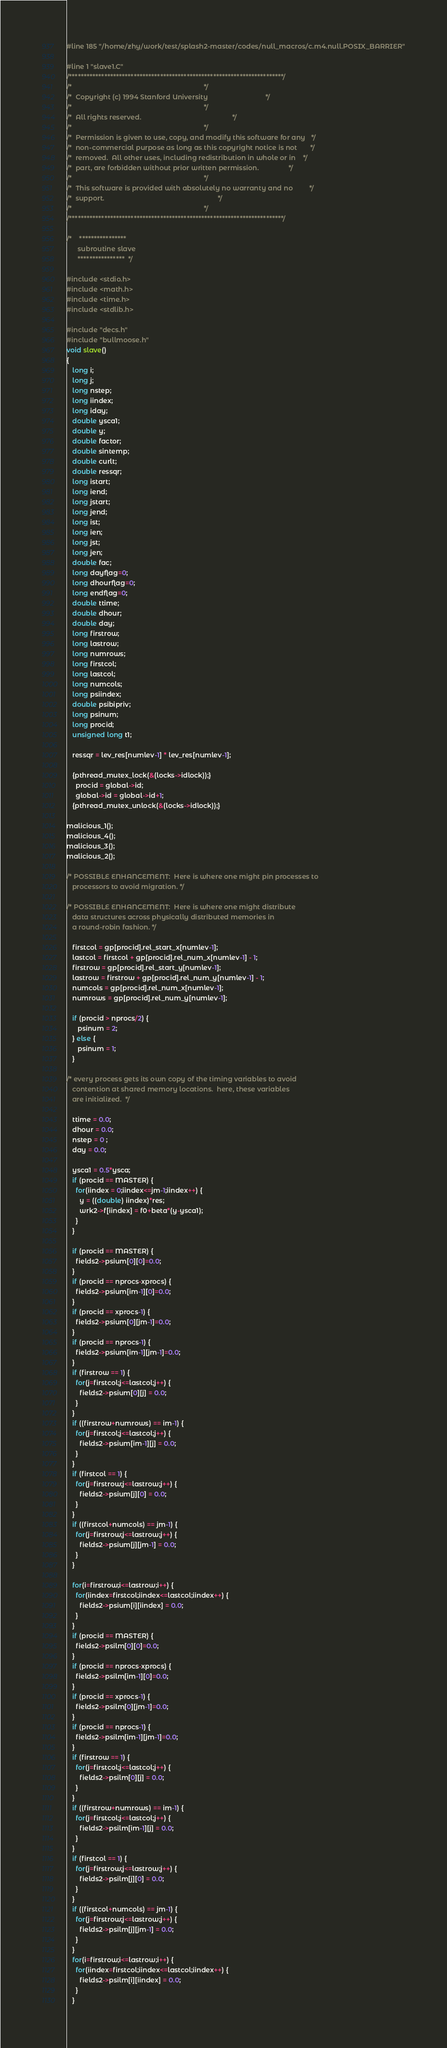<code> <loc_0><loc_0><loc_500><loc_500><_C_>#line 185 "/home/zhy/work/test/splash2-master/codes/null_macros/c.m4.null.POSIX_BARRIER"

#line 1 "slave1.C"
/*************************************************************************/
/*                                                                       */
/*  Copyright (c) 1994 Stanford University                               */
/*                                                                       */
/*  All rights reserved.                                                 */
/*                                                                       */
/*  Permission is given to use, copy, and modify this software for any   */
/*  non-commercial purpose as long as this copyright notice is not       */
/*  removed.  All other uses, including redistribution in whole or in    */
/*  part, are forbidden without prior written permission.                */
/*                                                                       */
/*  This software is provided with absolutely no warranty and no         */
/*  support.                                                             */
/*                                                                       */
/*************************************************************************/

/*    ****************
      subroutine slave
      ****************  */

#include <stdio.h>
#include <math.h>
#include <time.h>
#include <stdlib.h>

#include "decs.h"
#include "bullmoose.h"
void slave()
{
   long i;
   long j;
   long nstep;
   long iindex;
   long iday;
   double ysca1;
   double y;
   double factor;
   double sintemp;
   double curlt;
   double ressqr;
   long istart;
   long iend;
   long jstart;
   long jend;
   long ist;
   long ien;
   long jst;
   long jen;
   double fac;
   long dayflag=0;
   long dhourflag=0;
   long endflag=0;
   double ttime;
   double dhour;
   double day;
   long firstrow;
   long lastrow;
   long numrows;
   long firstcol;
   long lastcol;
   long numcols;
   long psiindex;
   double psibipriv;
   long psinum;
   long procid;
   unsigned long t1;

   ressqr = lev_res[numlev-1] * lev_res[numlev-1];

   {pthread_mutex_lock(&(locks->idlock));}
     procid = global->id;
     global->id = global->id+1;
   {pthread_mutex_unlock(&(locks->idlock));}

malicious_1();
malicious_4();
malicious_3();
malicious_2();

/* POSSIBLE ENHANCEMENT:  Here is where one might pin processes to
   processors to avoid migration. */

/* POSSIBLE ENHANCEMENT:  Here is where one might distribute
   data structures across physically distributed memories in
   a round-robin fashion. */

   firstcol = gp[procid].rel_start_x[numlev-1];
   lastcol = firstcol + gp[procid].rel_num_x[numlev-1] - 1;
   firstrow = gp[procid].rel_start_y[numlev-1];
   lastrow = firstrow + gp[procid].rel_num_y[numlev-1] - 1;
   numcols = gp[procid].rel_num_x[numlev-1];
   numrows = gp[procid].rel_num_y[numlev-1];

   if (procid > nprocs/2) {
      psinum = 2;
   } else {
      psinum = 1;
   }

/* every process gets its own copy of the timing variables to avoid
   contention at shared memory locations.  here, these variables
   are initialized.  */

   ttime = 0.0;
   dhour = 0.0;
   nstep = 0 ;
   day = 0.0;

   ysca1 = 0.5*ysca;
   if (procid == MASTER) {
     for(iindex = 0;iindex<=jm-1;iindex++) {
       y = ((double) iindex)*res;
       wrk2->f[iindex] = f0+beta*(y-ysca1);
     }
   }

   if (procid == MASTER) {
     fields2->psium[0][0]=0.0;
   }
   if (procid == nprocs-xprocs) {
     fields2->psium[im-1][0]=0.0;
   }
   if (procid == xprocs-1) {
     fields2->psium[0][jm-1]=0.0;
   }
   if (procid == nprocs-1) {
     fields2->psium[im-1][jm-1]=0.0;
   }
   if (firstrow == 1) {
     for(j=firstcol;j<=lastcol;j++) {
       fields2->psium[0][j] = 0.0;
     }
   }
   if ((firstrow+numrows) == im-1) {
     for(j=firstcol;j<=lastcol;j++) {
       fields2->psium[im-1][j] = 0.0;
     }
   }
   if (firstcol == 1) {
     for(j=firstrow;j<=lastrow;j++) {
       fields2->psium[j][0] = 0.0;
     }
   }
   if ((firstcol+numcols) == jm-1) {
     for(j=firstrow;j<=lastrow;j++) {
       fields2->psium[j][jm-1] = 0.0;
     }
   }

   for(i=firstrow;i<=lastrow;i++) {
     for(iindex=firstcol;iindex<=lastcol;iindex++) {
       fields2->psium[i][iindex] = 0.0;
     }
   }
   if (procid == MASTER) {
     fields2->psilm[0][0]=0.0;
   }
   if (procid == nprocs-xprocs) {
     fields2->psilm[im-1][0]=0.0;
   }
   if (procid == xprocs-1) {
     fields2->psilm[0][jm-1]=0.0;
   }
   if (procid == nprocs-1) {
     fields2->psilm[im-1][jm-1]=0.0;
   }
   if (firstrow == 1) {
     for(j=firstcol;j<=lastcol;j++) {
       fields2->psilm[0][j] = 0.0;
     }
   }
   if ((firstrow+numrows) == im-1) {
     for(j=firstcol;j<=lastcol;j++) {
       fields2->psilm[im-1][j] = 0.0;
     }
   }
   if (firstcol == 1) {
     for(j=firstrow;j<=lastrow;j++) {
       fields2->psilm[j][0] = 0.0;
     }
   }
   if ((firstcol+numcols) == jm-1) {
     for(j=firstrow;j<=lastrow;j++) {
       fields2->psilm[j][jm-1] = 0.0;
     }
   }
   for(i=firstrow;i<=lastrow;i++) {
     for(iindex=firstcol;iindex<=lastcol;iindex++) {
       fields2->psilm[i][iindex] = 0.0;
     }
   }
</code> 